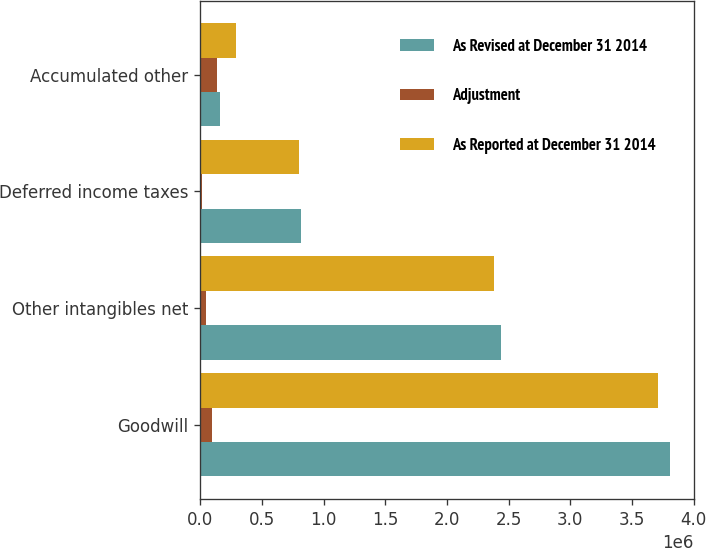Convert chart to OTSL. <chart><loc_0><loc_0><loc_500><loc_500><stacked_bar_chart><ecel><fcel>Goodwill<fcel>Other intangibles net<fcel>Deferred income taxes<fcel>Accumulated other<nl><fcel>As Revised at December 31 2014<fcel>3.81186e+06<fcel>2.43737e+06<fcel>815169<fcel>156933<nl><fcel>Adjustment<fcel>98680<fcel>51125<fcel>15230<fcel>134575<nl><fcel>As Reported at December 31 2014<fcel>3.71318e+06<fcel>2.38624e+06<fcel>799939<fcel>291508<nl></chart> 